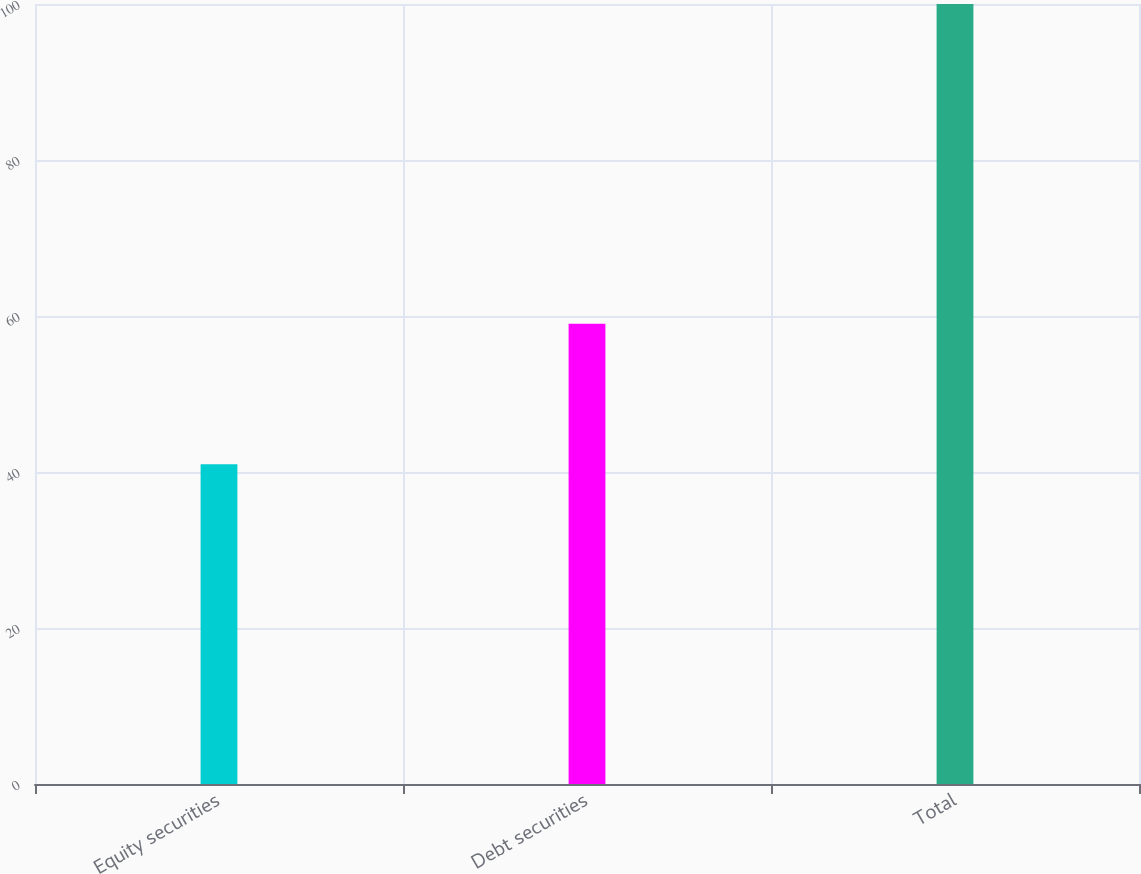Convert chart to OTSL. <chart><loc_0><loc_0><loc_500><loc_500><bar_chart><fcel>Equity securities<fcel>Debt securities<fcel>Total<nl><fcel>41<fcel>59<fcel>100<nl></chart> 